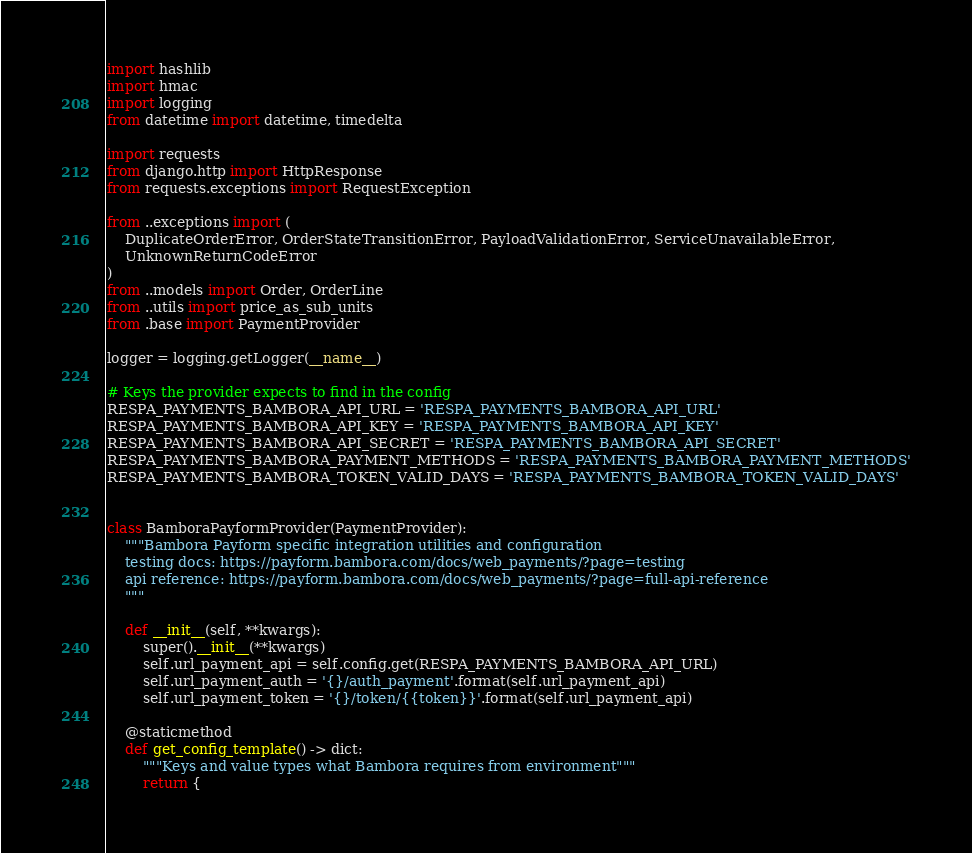<code> <loc_0><loc_0><loc_500><loc_500><_Python_>import hashlib
import hmac
import logging
from datetime import datetime, timedelta

import requests
from django.http import HttpResponse
from requests.exceptions import RequestException

from ..exceptions import (
    DuplicateOrderError, OrderStateTransitionError, PayloadValidationError, ServiceUnavailableError,
    UnknownReturnCodeError
)
from ..models import Order, OrderLine
from ..utils import price_as_sub_units
from .base import PaymentProvider

logger = logging.getLogger(__name__)

# Keys the provider expects to find in the config
RESPA_PAYMENTS_BAMBORA_API_URL = 'RESPA_PAYMENTS_BAMBORA_API_URL'
RESPA_PAYMENTS_BAMBORA_API_KEY = 'RESPA_PAYMENTS_BAMBORA_API_KEY'
RESPA_PAYMENTS_BAMBORA_API_SECRET = 'RESPA_PAYMENTS_BAMBORA_API_SECRET'
RESPA_PAYMENTS_BAMBORA_PAYMENT_METHODS = 'RESPA_PAYMENTS_BAMBORA_PAYMENT_METHODS'
RESPA_PAYMENTS_BAMBORA_TOKEN_VALID_DAYS = 'RESPA_PAYMENTS_BAMBORA_TOKEN_VALID_DAYS'


class BamboraPayformProvider(PaymentProvider):
    """Bambora Payform specific integration utilities and configuration
    testing docs: https://payform.bambora.com/docs/web_payments/?page=testing
    api reference: https://payform.bambora.com/docs/web_payments/?page=full-api-reference
    """

    def __init__(self, **kwargs):
        super().__init__(**kwargs)
        self.url_payment_api = self.config.get(RESPA_PAYMENTS_BAMBORA_API_URL)
        self.url_payment_auth = '{}/auth_payment'.format(self.url_payment_api)
        self.url_payment_token = '{}/token/{{token}}'.format(self.url_payment_api)

    @staticmethod
    def get_config_template() -> dict:
        """Keys and value types what Bambora requires from environment"""
        return {</code> 